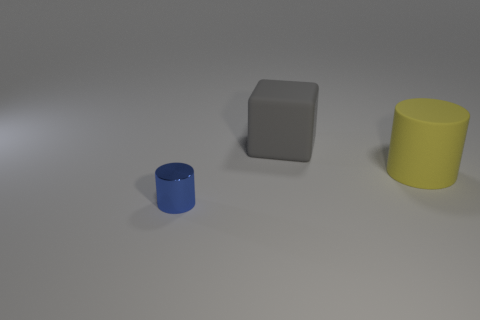Add 1 blue metallic objects. How many objects exist? 4 Subtract all blocks. How many objects are left? 2 Subtract all gray things. Subtract all yellow rubber cylinders. How many objects are left? 1 Add 2 gray rubber blocks. How many gray rubber blocks are left? 3 Add 1 blue metal things. How many blue metal things exist? 2 Subtract 0 green balls. How many objects are left? 3 